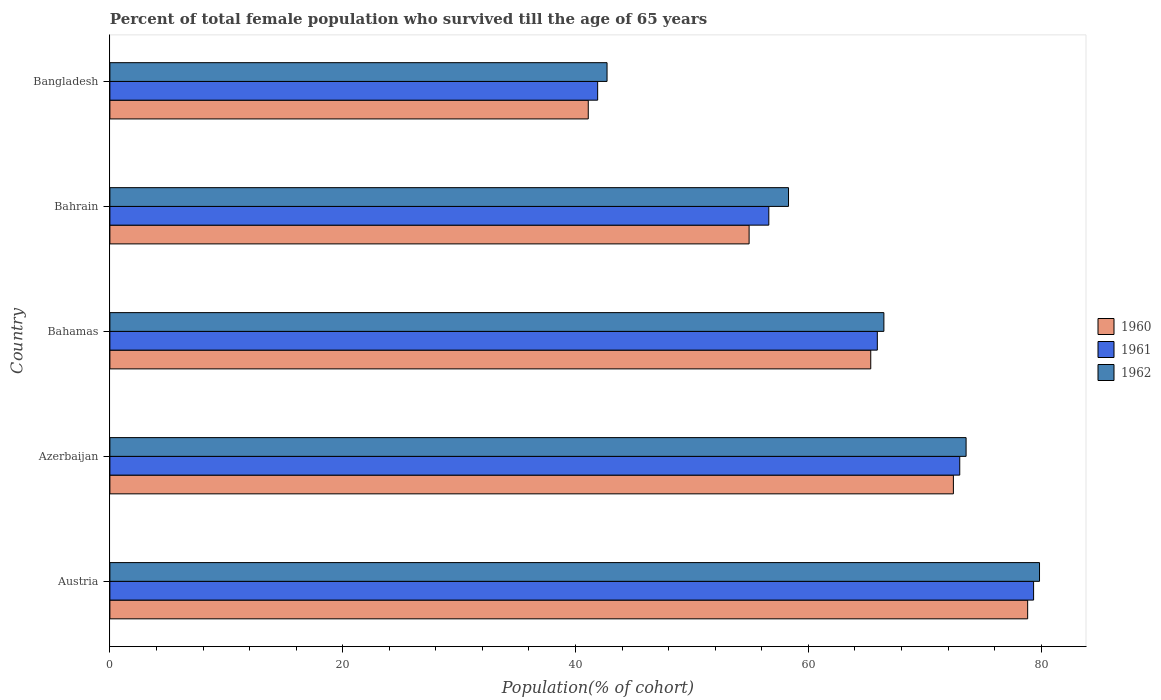How many different coloured bars are there?
Keep it short and to the point. 3. How many bars are there on the 2nd tick from the top?
Ensure brevity in your answer.  3. How many bars are there on the 1st tick from the bottom?
Ensure brevity in your answer.  3. What is the label of the 4th group of bars from the top?
Provide a succinct answer. Azerbaijan. In how many cases, is the number of bars for a given country not equal to the number of legend labels?
Your answer should be compact. 0. What is the percentage of total female population who survived till the age of 65 years in 1962 in Bangladesh?
Give a very brief answer. 42.71. Across all countries, what is the maximum percentage of total female population who survived till the age of 65 years in 1960?
Ensure brevity in your answer.  78.84. Across all countries, what is the minimum percentage of total female population who survived till the age of 65 years in 1962?
Ensure brevity in your answer.  42.71. In which country was the percentage of total female population who survived till the age of 65 years in 1960 maximum?
Offer a very short reply. Austria. What is the total percentage of total female population who survived till the age of 65 years in 1960 in the graph?
Give a very brief answer. 312.66. What is the difference between the percentage of total female population who survived till the age of 65 years in 1960 in Austria and that in Bahamas?
Keep it short and to the point. 13.48. What is the difference between the percentage of total female population who survived till the age of 65 years in 1961 in Bahamas and the percentage of total female population who survived till the age of 65 years in 1962 in Austria?
Make the answer very short. -13.93. What is the average percentage of total female population who survived till the age of 65 years in 1962 per country?
Offer a terse response. 64.18. What is the difference between the percentage of total female population who survived till the age of 65 years in 1960 and percentage of total female population who survived till the age of 65 years in 1961 in Azerbaijan?
Keep it short and to the point. -0.55. What is the ratio of the percentage of total female population who survived till the age of 65 years in 1962 in Austria to that in Azerbaijan?
Offer a terse response. 1.09. Is the percentage of total female population who survived till the age of 65 years in 1961 in Austria less than that in Bahrain?
Give a very brief answer. No. Is the difference between the percentage of total female population who survived till the age of 65 years in 1960 in Azerbaijan and Bangladesh greater than the difference between the percentage of total female population who survived till the age of 65 years in 1961 in Azerbaijan and Bangladesh?
Offer a terse response. Yes. What is the difference between the highest and the second highest percentage of total female population who survived till the age of 65 years in 1961?
Provide a succinct answer. 6.34. What is the difference between the highest and the lowest percentage of total female population who survived till the age of 65 years in 1962?
Your answer should be very brief. 37.15. In how many countries, is the percentage of total female population who survived till the age of 65 years in 1962 greater than the average percentage of total female population who survived till the age of 65 years in 1962 taken over all countries?
Offer a terse response. 3. Is it the case that in every country, the sum of the percentage of total female population who survived till the age of 65 years in 1962 and percentage of total female population who survived till the age of 65 years in 1960 is greater than the percentage of total female population who survived till the age of 65 years in 1961?
Make the answer very short. Yes. Are all the bars in the graph horizontal?
Offer a very short reply. Yes. How many countries are there in the graph?
Keep it short and to the point. 5. Does the graph contain grids?
Offer a very short reply. No. Where does the legend appear in the graph?
Offer a terse response. Center right. How many legend labels are there?
Give a very brief answer. 3. How are the legend labels stacked?
Make the answer very short. Vertical. What is the title of the graph?
Keep it short and to the point. Percent of total female population who survived till the age of 65 years. Does "1960" appear as one of the legend labels in the graph?
Your response must be concise. Yes. What is the label or title of the X-axis?
Offer a very short reply. Population(% of cohort). What is the label or title of the Y-axis?
Provide a short and direct response. Country. What is the Population(% of cohort) of 1960 in Austria?
Give a very brief answer. 78.84. What is the Population(% of cohort) in 1961 in Austria?
Give a very brief answer. 79.35. What is the Population(% of cohort) in 1962 in Austria?
Keep it short and to the point. 79.86. What is the Population(% of cohort) of 1960 in Azerbaijan?
Your answer should be very brief. 72.46. What is the Population(% of cohort) of 1961 in Azerbaijan?
Your answer should be compact. 73. What is the Population(% of cohort) in 1962 in Azerbaijan?
Keep it short and to the point. 73.55. What is the Population(% of cohort) of 1960 in Bahamas?
Your answer should be compact. 65.36. What is the Population(% of cohort) in 1961 in Bahamas?
Provide a short and direct response. 65.92. What is the Population(% of cohort) of 1962 in Bahamas?
Your answer should be compact. 66.49. What is the Population(% of cohort) of 1960 in Bahrain?
Your response must be concise. 54.91. What is the Population(% of cohort) of 1961 in Bahrain?
Ensure brevity in your answer.  56.6. What is the Population(% of cohort) of 1962 in Bahrain?
Provide a succinct answer. 58.3. What is the Population(% of cohort) of 1960 in Bangladesh?
Keep it short and to the point. 41.09. What is the Population(% of cohort) of 1961 in Bangladesh?
Your response must be concise. 41.9. What is the Population(% of cohort) of 1962 in Bangladesh?
Provide a short and direct response. 42.71. Across all countries, what is the maximum Population(% of cohort) of 1960?
Offer a very short reply. 78.84. Across all countries, what is the maximum Population(% of cohort) of 1961?
Your answer should be compact. 79.35. Across all countries, what is the maximum Population(% of cohort) of 1962?
Offer a very short reply. 79.86. Across all countries, what is the minimum Population(% of cohort) of 1960?
Keep it short and to the point. 41.09. Across all countries, what is the minimum Population(% of cohort) of 1961?
Your answer should be very brief. 41.9. Across all countries, what is the minimum Population(% of cohort) in 1962?
Your response must be concise. 42.71. What is the total Population(% of cohort) of 1960 in the graph?
Your response must be concise. 312.66. What is the total Population(% of cohort) of 1961 in the graph?
Give a very brief answer. 316.78. What is the total Population(% of cohort) in 1962 in the graph?
Make the answer very short. 320.9. What is the difference between the Population(% of cohort) in 1960 in Austria and that in Azerbaijan?
Make the answer very short. 6.38. What is the difference between the Population(% of cohort) of 1961 in Austria and that in Azerbaijan?
Keep it short and to the point. 6.34. What is the difference between the Population(% of cohort) of 1962 in Austria and that in Azerbaijan?
Provide a short and direct response. 6.31. What is the difference between the Population(% of cohort) in 1960 in Austria and that in Bahamas?
Your response must be concise. 13.48. What is the difference between the Population(% of cohort) in 1961 in Austria and that in Bahamas?
Keep it short and to the point. 13.42. What is the difference between the Population(% of cohort) of 1962 in Austria and that in Bahamas?
Provide a succinct answer. 13.37. What is the difference between the Population(% of cohort) in 1960 in Austria and that in Bahrain?
Provide a short and direct response. 23.93. What is the difference between the Population(% of cohort) of 1961 in Austria and that in Bahrain?
Provide a succinct answer. 22.75. What is the difference between the Population(% of cohort) in 1962 in Austria and that in Bahrain?
Make the answer very short. 21.56. What is the difference between the Population(% of cohort) in 1960 in Austria and that in Bangladesh?
Offer a very short reply. 37.75. What is the difference between the Population(% of cohort) of 1961 in Austria and that in Bangladesh?
Your response must be concise. 37.45. What is the difference between the Population(% of cohort) in 1962 in Austria and that in Bangladesh?
Keep it short and to the point. 37.15. What is the difference between the Population(% of cohort) of 1960 in Azerbaijan and that in Bahamas?
Offer a terse response. 7.1. What is the difference between the Population(% of cohort) of 1961 in Azerbaijan and that in Bahamas?
Your answer should be compact. 7.08. What is the difference between the Population(% of cohort) in 1962 in Azerbaijan and that in Bahamas?
Keep it short and to the point. 7.06. What is the difference between the Population(% of cohort) of 1960 in Azerbaijan and that in Bahrain?
Keep it short and to the point. 17.55. What is the difference between the Population(% of cohort) of 1961 in Azerbaijan and that in Bahrain?
Provide a short and direct response. 16.4. What is the difference between the Population(% of cohort) in 1962 in Azerbaijan and that in Bahrain?
Your response must be concise. 15.25. What is the difference between the Population(% of cohort) in 1960 in Azerbaijan and that in Bangladesh?
Give a very brief answer. 31.37. What is the difference between the Population(% of cohort) in 1961 in Azerbaijan and that in Bangladesh?
Give a very brief answer. 31.1. What is the difference between the Population(% of cohort) in 1962 in Azerbaijan and that in Bangladesh?
Offer a terse response. 30.84. What is the difference between the Population(% of cohort) in 1960 in Bahamas and that in Bahrain?
Offer a terse response. 10.45. What is the difference between the Population(% of cohort) in 1961 in Bahamas and that in Bahrain?
Provide a succinct answer. 9.32. What is the difference between the Population(% of cohort) of 1962 in Bahamas and that in Bahrain?
Offer a terse response. 8.19. What is the difference between the Population(% of cohort) of 1960 in Bahamas and that in Bangladesh?
Make the answer very short. 24.27. What is the difference between the Population(% of cohort) in 1961 in Bahamas and that in Bangladesh?
Make the answer very short. 24.02. What is the difference between the Population(% of cohort) in 1962 in Bahamas and that in Bangladesh?
Keep it short and to the point. 23.78. What is the difference between the Population(% of cohort) in 1960 in Bahrain and that in Bangladesh?
Give a very brief answer. 13.82. What is the difference between the Population(% of cohort) in 1961 in Bahrain and that in Bangladesh?
Offer a terse response. 14.7. What is the difference between the Population(% of cohort) of 1962 in Bahrain and that in Bangladesh?
Your answer should be compact. 15.59. What is the difference between the Population(% of cohort) of 1960 in Austria and the Population(% of cohort) of 1961 in Azerbaijan?
Offer a very short reply. 5.83. What is the difference between the Population(% of cohort) of 1960 in Austria and the Population(% of cohort) of 1962 in Azerbaijan?
Your response must be concise. 5.29. What is the difference between the Population(% of cohort) of 1961 in Austria and the Population(% of cohort) of 1962 in Azerbaijan?
Make the answer very short. 5.8. What is the difference between the Population(% of cohort) in 1960 in Austria and the Population(% of cohort) in 1961 in Bahamas?
Your answer should be very brief. 12.91. What is the difference between the Population(% of cohort) of 1960 in Austria and the Population(% of cohort) of 1962 in Bahamas?
Offer a terse response. 12.35. What is the difference between the Population(% of cohort) in 1961 in Austria and the Population(% of cohort) in 1962 in Bahamas?
Give a very brief answer. 12.86. What is the difference between the Population(% of cohort) in 1960 in Austria and the Population(% of cohort) in 1961 in Bahrain?
Your answer should be very brief. 22.24. What is the difference between the Population(% of cohort) in 1960 in Austria and the Population(% of cohort) in 1962 in Bahrain?
Make the answer very short. 20.54. What is the difference between the Population(% of cohort) of 1961 in Austria and the Population(% of cohort) of 1962 in Bahrain?
Make the answer very short. 21.05. What is the difference between the Population(% of cohort) of 1960 in Austria and the Population(% of cohort) of 1961 in Bangladesh?
Offer a terse response. 36.94. What is the difference between the Population(% of cohort) of 1960 in Austria and the Population(% of cohort) of 1962 in Bangladesh?
Your answer should be very brief. 36.13. What is the difference between the Population(% of cohort) in 1961 in Austria and the Population(% of cohort) in 1962 in Bangladesh?
Provide a succinct answer. 36.64. What is the difference between the Population(% of cohort) of 1960 in Azerbaijan and the Population(% of cohort) of 1961 in Bahamas?
Ensure brevity in your answer.  6.54. What is the difference between the Population(% of cohort) in 1960 in Azerbaijan and the Population(% of cohort) in 1962 in Bahamas?
Your answer should be compact. 5.97. What is the difference between the Population(% of cohort) in 1961 in Azerbaijan and the Population(% of cohort) in 1962 in Bahamas?
Ensure brevity in your answer.  6.52. What is the difference between the Population(% of cohort) of 1960 in Azerbaijan and the Population(% of cohort) of 1961 in Bahrain?
Offer a very short reply. 15.86. What is the difference between the Population(% of cohort) of 1960 in Azerbaijan and the Population(% of cohort) of 1962 in Bahrain?
Offer a very short reply. 14.16. What is the difference between the Population(% of cohort) of 1961 in Azerbaijan and the Population(% of cohort) of 1962 in Bahrain?
Provide a succinct answer. 14.71. What is the difference between the Population(% of cohort) of 1960 in Azerbaijan and the Population(% of cohort) of 1961 in Bangladesh?
Your answer should be very brief. 30.56. What is the difference between the Population(% of cohort) in 1960 in Azerbaijan and the Population(% of cohort) in 1962 in Bangladesh?
Keep it short and to the point. 29.75. What is the difference between the Population(% of cohort) in 1961 in Azerbaijan and the Population(% of cohort) in 1962 in Bangladesh?
Your response must be concise. 30.3. What is the difference between the Population(% of cohort) of 1960 in Bahamas and the Population(% of cohort) of 1961 in Bahrain?
Provide a short and direct response. 8.76. What is the difference between the Population(% of cohort) of 1960 in Bahamas and the Population(% of cohort) of 1962 in Bahrain?
Give a very brief answer. 7.07. What is the difference between the Population(% of cohort) of 1961 in Bahamas and the Population(% of cohort) of 1962 in Bahrain?
Provide a succinct answer. 7.63. What is the difference between the Population(% of cohort) in 1960 in Bahamas and the Population(% of cohort) in 1961 in Bangladesh?
Offer a terse response. 23.46. What is the difference between the Population(% of cohort) of 1960 in Bahamas and the Population(% of cohort) of 1962 in Bangladesh?
Your answer should be compact. 22.65. What is the difference between the Population(% of cohort) of 1961 in Bahamas and the Population(% of cohort) of 1962 in Bangladesh?
Give a very brief answer. 23.22. What is the difference between the Population(% of cohort) of 1960 in Bahrain and the Population(% of cohort) of 1961 in Bangladesh?
Your response must be concise. 13.01. What is the difference between the Population(% of cohort) of 1960 in Bahrain and the Population(% of cohort) of 1962 in Bangladesh?
Keep it short and to the point. 12.2. What is the difference between the Population(% of cohort) of 1961 in Bahrain and the Population(% of cohort) of 1962 in Bangladesh?
Give a very brief answer. 13.9. What is the average Population(% of cohort) in 1960 per country?
Provide a short and direct response. 62.53. What is the average Population(% of cohort) of 1961 per country?
Give a very brief answer. 63.36. What is the average Population(% of cohort) in 1962 per country?
Keep it short and to the point. 64.18. What is the difference between the Population(% of cohort) in 1960 and Population(% of cohort) in 1961 in Austria?
Provide a short and direct response. -0.51. What is the difference between the Population(% of cohort) in 1960 and Population(% of cohort) in 1962 in Austria?
Provide a short and direct response. -1.02. What is the difference between the Population(% of cohort) in 1961 and Population(% of cohort) in 1962 in Austria?
Your response must be concise. -0.51. What is the difference between the Population(% of cohort) in 1960 and Population(% of cohort) in 1961 in Azerbaijan?
Your response must be concise. -0.55. What is the difference between the Population(% of cohort) in 1960 and Population(% of cohort) in 1962 in Azerbaijan?
Your response must be concise. -1.09. What is the difference between the Population(% of cohort) of 1961 and Population(% of cohort) of 1962 in Azerbaijan?
Give a very brief answer. -0.55. What is the difference between the Population(% of cohort) of 1960 and Population(% of cohort) of 1961 in Bahamas?
Give a very brief answer. -0.56. What is the difference between the Population(% of cohort) of 1960 and Population(% of cohort) of 1962 in Bahamas?
Give a very brief answer. -1.13. What is the difference between the Population(% of cohort) of 1961 and Population(% of cohort) of 1962 in Bahamas?
Ensure brevity in your answer.  -0.56. What is the difference between the Population(% of cohort) in 1960 and Population(% of cohort) in 1961 in Bahrain?
Provide a succinct answer. -1.69. What is the difference between the Population(% of cohort) in 1960 and Population(% of cohort) in 1962 in Bahrain?
Your response must be concise. -3.38. What is the difference between the Population(% of cohort) of 1961 and Population(% of cohort) of 1962 in Bahrain?
Provide a short and direct response. -1.69. What is the difference between the Population(% of cohort) in 1960 and Population(% of cohort) in 1961 in Bangladesh?
Give a very brief answer. -0.81. What is the difference between the Population(% of cohort) in 1960 and Population(% of cohort) in 1962 in Bangladesh?
Offer a very short reply. -1.61. What is the difference between the Population(% of cohort) of 1961 and Population(% of cohort) of 1962 in Bangladesh?
Your response must be concise. -0.81. What is the ratio of the Population(% of cohort) of 1960 in Austria to that in Azerbaijan?
Make the answer very short. 1.09. What is the ratio of the Population(% of cohort) of 1961 in Austria to that in Azerbaijan?
Offer a terse response. 1.09. What is the ratio of the Population(% of cohort) of 1962 in Austria to that in Azerbaijan?
Keep it short and to the point. 1.09. What is the ratio of the Population(% of cohort) in 1960 in Austria to that in Bahamas?
Your answer should be compact. 1.21. What is the ratio of the Population(% of cohort) in 1961 in Austria to that in Bahamas?
Make the answer very short. 1.2. What is the ratio of the Population(% of cohort) of 1962 in Austria to that in Bahamas?
Give a very brief answer. 1.2. What is the ratio of the Population(% of cohort) in 1960 in Austria to that in Bahrain?
Keep it short and to the point. 1.44. What is the ratio of the Population(% of cohort) of 1961 in Austria to that in Bahrain?
Provide a short and direct response. 1.4. What is the ratio of the Population(% of cohort) in 1962 in Austria to that in Bahrain?
Your answer should be very brief. 1.37. What is the ratio of the Population(% of cohort) in 1960 in Austria to that in Bangladesh?
Provide a short and direct response. 1.92. What is the ratio of the Population(% of cohort) in 1961 in Austria to that in Bangladesh?
Give a very brief answer. 1.89. What is the ratio of the Population(% of cohort) of 1962 in Austria to that in Bangladesh?
Your answer should be compact. 1.87. What is the ratio of the Population(% of cohort) of 1960 in Azerbaijan to that in Bahamas?
Provide a short and direct response. 1.11. What is the ratio of the Population(% of cohort) in 1961 in Azerbaijan to that in Bahamas?
Ensure brevity in your answer.  1.11. What is the ratio of the Population(% of cohort) of 1962 in Azerbaijan to that in Bahamas?
Offer a terse response. 1.11. What is the ratio of the Population(% of cohort) of 1960 in Azerbaijan to that in Bahrain?
Make the answer very short. 1.32. What is the ratio of the Population(% of cohort) in 1961 in Azerbaijan to that in Bahrain?
Give a very brief answer. 1.29. What is the ratio of the Population(% of cohort) of 1962 in Azerbaijan to that in Bahrain?
Make the answer very short. 1.26. What is the ratio of the Population(% of cohort) in 1960 in Azerbaijan to that in Bangladesh?
Make the answer very short. 1.76. What is the ratio of the Population(% of cohort) of 1961 in Azerbaijan to that in Bangladesh?
Your answer should be very brief. 1.74. What is the ratio of the Population(% of cohort) in 1962 in Azerbaijan to that in Bangladesh?
Keep it short and to the point. 1.72. What is the ratio of the Population(% of cohort) of 1960 in Bahamas to that in Bahrain?
Provide a succinct answer. 1.19. What is the ratio of the Population(% of cohort) of 1961 in Bahamas to that in Bahrain?
Provide a short and direct response. 1.16. What is the ratio of the Population(% of cohort) of 1962 in Bahamas to that in Bahrain?
Your answer should be compact. 1.14. What is the ratio of the Population(% of cohort) in 1960 in Bahamas to that in Bangladesh?
Give a very brief answer. 1.59. What is the ratio of the Population(% of cohort) in 1961 in Bahamas to that in Bangladesh?
Offer a terse response. 1.57. What is the ratio of the Population(% of cohort) in 1962 in Bahamas to that in Bangladesh?
Your answer should be very brief. 1.56. What is the ratio of the Population(% of cohort) of 1960 in Bahrain to that in Bangladesh?
Make the answer very short. 1.34. What is the ratio of the Population(% of cohort) of 1961 in Bahrain to that in Bangladesh?
Your answer should be very brief. 1.35. What is the ratio of the Population(% of cohort) in 1962 in Bahrain to that in Bangladesh?
Ensure brevity in your answer.  1.36. What is the difference between the highest and the second highest Population(% of cohort) of 1960?
Offer a terse response. 6.38. What is the difference between the highest and the second highest Population(% of cohort) of 1961?
Ensure brevity in your answer.  6.34. What is the difference between the highest and the second highest Population(% of cohort) of 1962?
Give a very brief answer. 6.31. What is the difference between the highest and the lowest Population(% of cohort) in 1960?
Keep it short and to the point. 37.75. What is the difference between the highest and the lowest Population(% of cohort) in 1961?
Make the answer very short. 37.45. What is the difference between the highest and the lowest Population(% of cohort) in 1962?
Your answer should be compact. 37.15. 